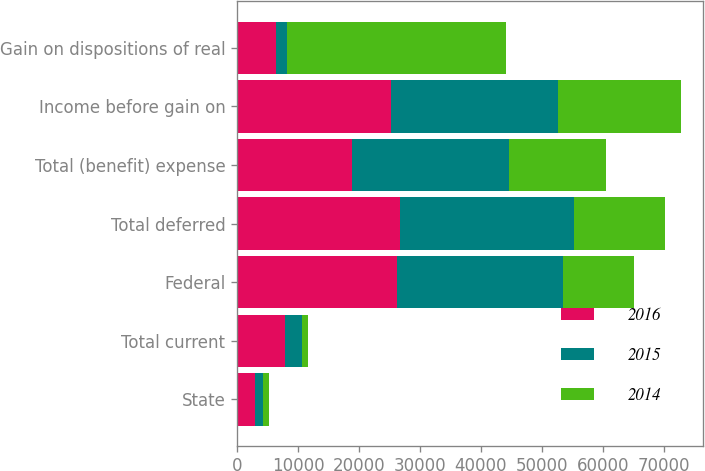Convert chart to OTSL. <chart><loc_0><loc_0><loc_500><loc_500><stacked_bar_chart><ecel><fcel>State<fcel>Total current<fcel>Federal<fcel>Total deferred<fcel>Total (benefit) expense<fcel>Income before gain on<fcel>Gain on dispositions of real<nl><fcel>2016<fcel>2916<fcel>7954<fcel>26173<fcel>26796<fcel>18842<fcel>25208<fcel>6366<nl><fcel>2015<fcel>1357<fcel>2667<fcel>27382<fcel>28434<fcel>25767<fcel>27524<fcel>1757<nl><fcel>2014<fcel>970<fcel>970<fcel>11556<fcel>15041<fcel>16011<fcel>20047<fcel>36058<nl></chart> 